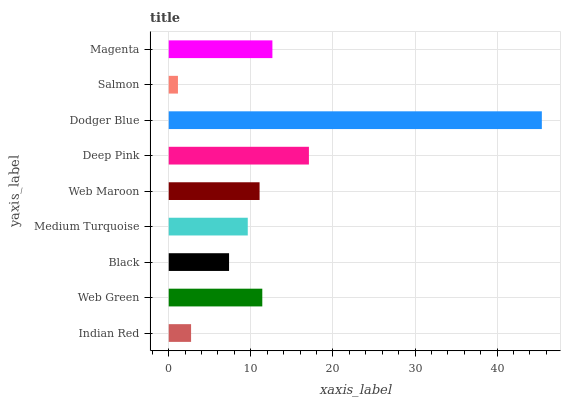Is Salmon the minimum?
Answer yes or no. Yes. Is Dodger Blue the maximum?
Answer yes or no. Yes. Is Web Green the minimum?
Answer yes or no. No. Is Web Green the maximum?
Answer yes or no. No. Is Web Green greater than Indian Red?
Answer yes or no. Yes. Is Indian Red less than Web Green?
Answer yes or no. Yes. Is Indian Red greater than Web Green?
Answer yes or no. No. Is Web Green less than Indian Red?
Answer yes or no. No. Is Web Maroon the high median?
Answer yes or no. Yes. Is Web Maroon the low median?
Answer yes or no. Yes. Is Web Green the high median?
Answer yes or no. No. Is Indian Red the low median?
Answer yes or no. No. 